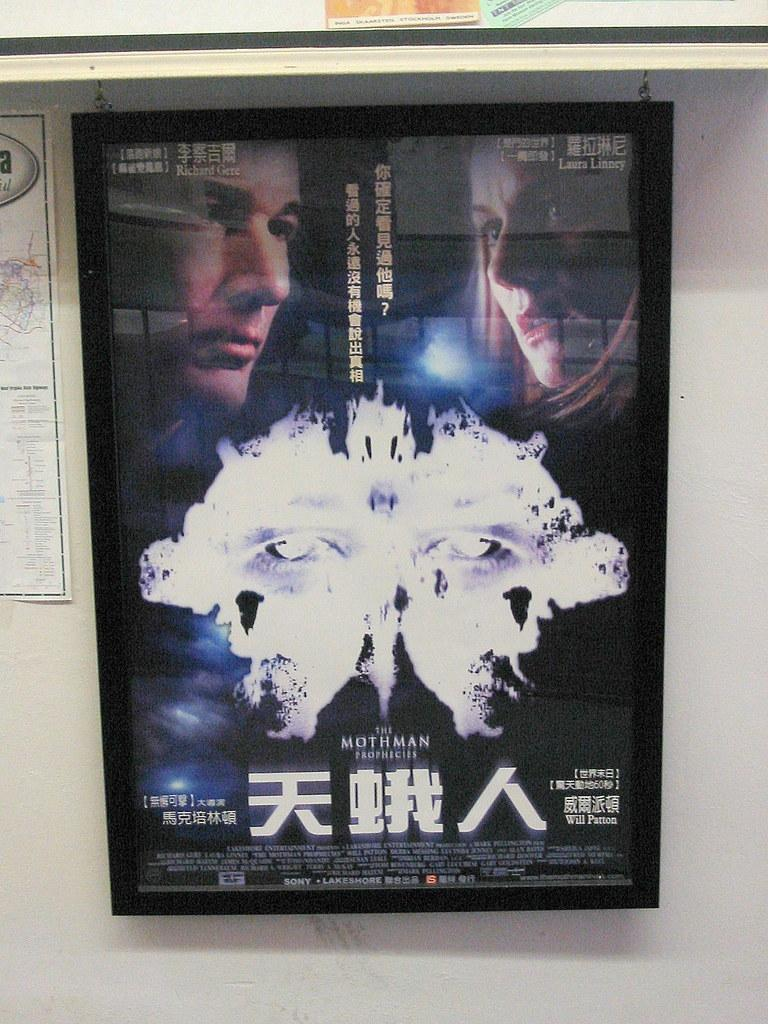<image>
Present a compact description of the photo's key features. a movie poster that is for a movie titled 'the mothman prophecies' 